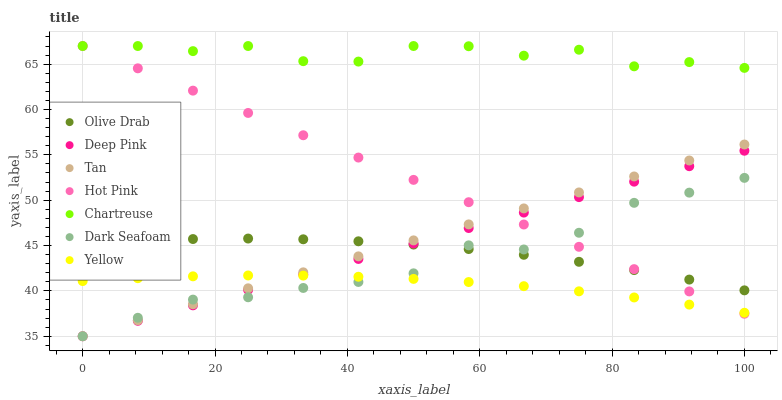Does Yellow have the minimum area under the curve?
Answer yes or no. Yes. Does Chartreuse have the maximum area under the curve?
Answer yes or no. Yes. Does Hot Pink have the minimum area under the curve?
Answer yes or no. No. Does Hot Pink have the maximum area under the curve?
Answer yes or no. No. Is Tan the smoothest?
Answer yes or no. Yes. Is Chartreuse the roughest?
Answer yes or no. Yes. Is Hot Pink the smoothest?
Answer yes or no. No. Is Hot Pink the roughest?
Answer yes or no. No. Does Deep Pink have the lowest value?
Answer yes or no. Yes. Does Hot Pink have the lowest value?
Answer yes or no. No. Does Chartreuse have the highest value?
Answer yes or no. Yes. Does Yellow have the highest value?
Answer yes or no. No. Is Yellow less than Chartreuse?
Answer yes or no. Yes. Is Olive Drab greater than Yellow?
Answer yes or no. Yes. Does Tan intersect Dark Seafoam?
Answer yes or no. Yes. Is Tan less than Dark Seafoam?
Answer yes or no. No. Is Tan greater than Dark Seafoam?
Answer yes or no. No. Does Yellow intersect Chartreuse?
Answer yes or no. No. 